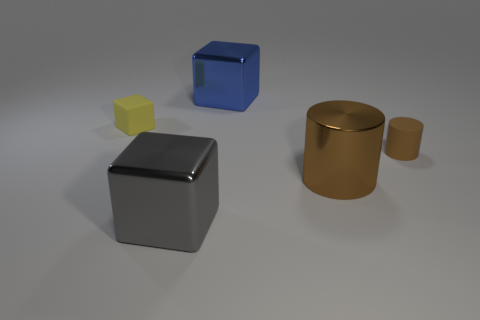Add 3 matte cylinders. How many objects exist? 8 Subtract all blocks. How many objects are left? 2 Add 4 green matte spheres. How many green matte spheres exist? 4 Subtract 0 blue cylinders. How many objects are left? 5 Subtract all big blue matte objects. Subtract all big brown objects. How many objects are left? 4 Add 1 large blue blocks. How many large blue blocks are left? 2 